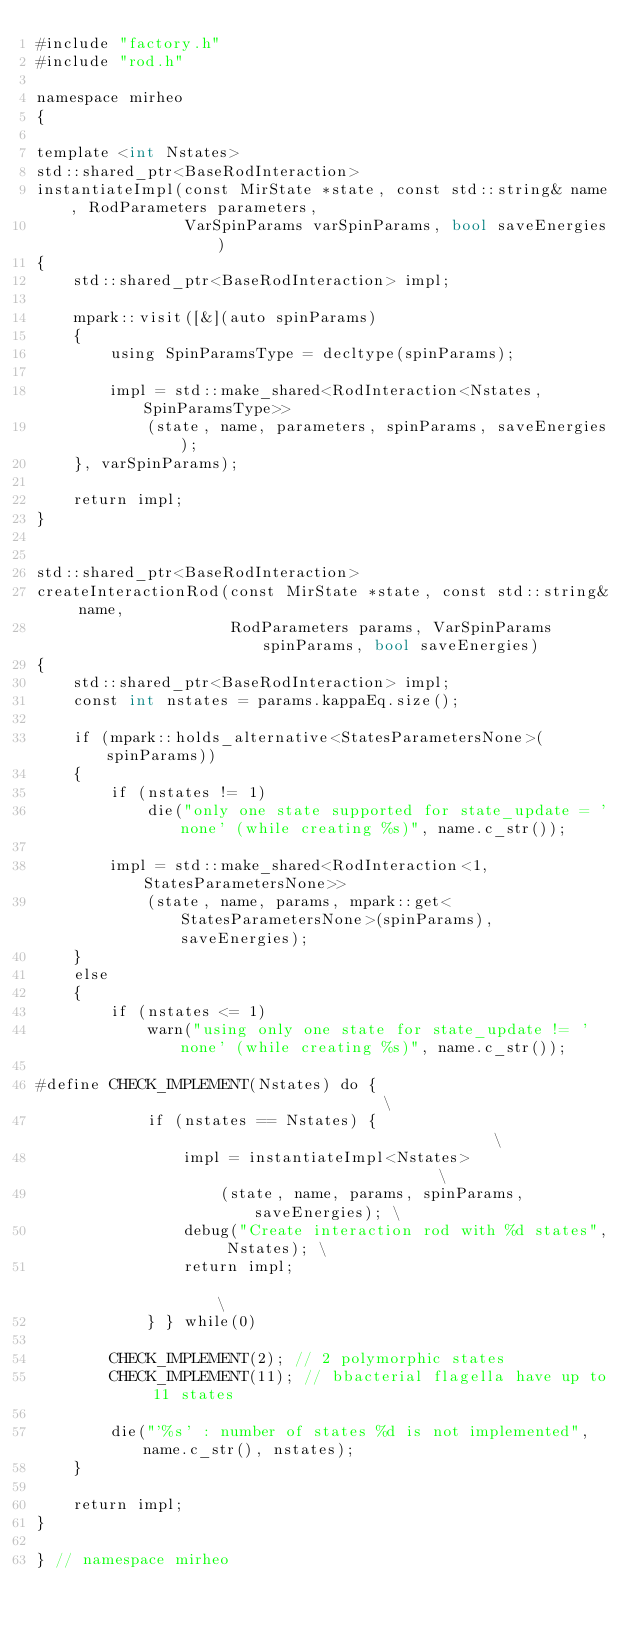Convert code to text. <code><loc_0><loc_0><loc_500><loc_500><_Cuda_>#include "factory.h"
#include "rod.h"

namespace mirheo
{

template <int Nstates>
std::shared_ptr<BaseRodInteraction>
instantiateImpl(const MirState *state, const std::string& name, RodParameters parameters,
                VarSpinParams varSpinParams, bool saveEnergies)
{
    std::shared_ptr<BaseRodInteraction> impl;

    mpark::visit([&](auto spinParams)
    {
        using SpinParamsType = decltype(spinParams);
        
        impl = std::make_shared<RodInteraction<Nstates, SpinParamsType>>
            (state, name, parameters, spinParams, saveEnergies);
    }, varSpinParams);

    return impl;
}


std::shared_ptr<BaseRodInteraction>
createInteractionRod(const MirState *state, const std::string& name,
                     RodParameters params, VarSpinParams spinParams, bool saveEnergies)
{
    std::shared_ptr<BaseRodInteraction> impl;
    const int nstates = params.kappaEq.size();

    if (mpark::holds_alternative<StatesParametersNone>(spinParams))
    {
        if (nstates != 1)
            die("only one state supported for state_update = 'none' (while creating %s)", name.c_str());

        impl = std::make_shared<RodInteraction<1, StatesParametersNone>>
            (state, name, params, mpark::get<StatesParametersNone>(spinParams), saveEnergies);
    }
    else
    {
        if (nstates <= 1)
            warn("using only one state for state_update != 'none' (while creating %s)", name.c_str());
        
#define CHECK_IMPLEMENT(Nstates) do {                                   \
            if (nstates == Nstates) {                                   \
                impl = instantiateImpl<Nstates>                         \
                    (state, name, params, spinParams, saveEnergies); \
                debug("Create interaction rod with %d states", Nstates); \
                return impl;                                                 \
            } } while(0)
        
        CHECK_IMPLEMENT(2); // 2 polymorphic states
        CHECK_IMPLEMENT(11); // bbacterial flagella have up to 11 states

        die("'%s' : number of states %d is not implemented", name.c_str(), nstates);
    }

    return impl;
}

} // namespace mirheo
</code> 